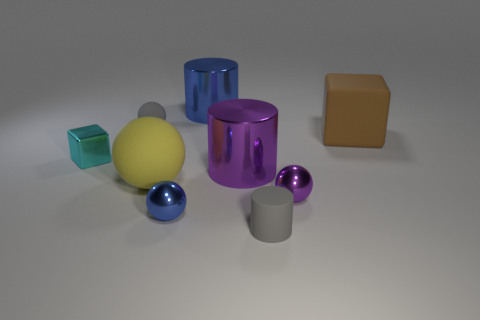What could be the function of the purple object? If this were a real-world object, the purple cylinder might serve as a container or a decorative piece, given its open top and aesthetically pleasing glossy finish. 